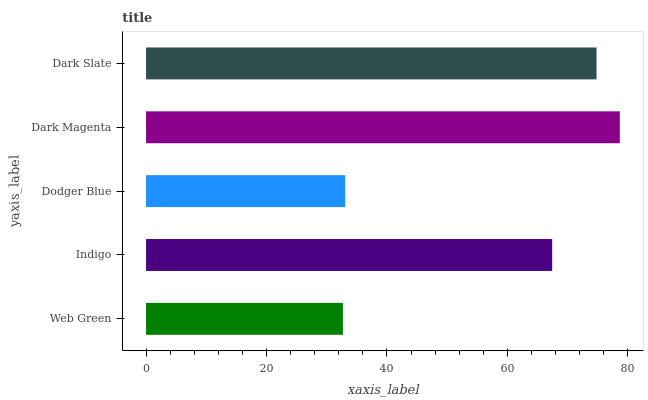Is Web Green the minimum?
Answer yes or no. Yes. Is Dark Magenta the maximum?
Answer yes or no. Yes. Is Indigo the minimum?
Answer yes or no. No. Is Indigo the maximum?
Answer yes or no. No. Is Indigo greater than Web Green?
Answer yes or no. Yes. Is Web Green less than Indigo?
Answer yes or no. Yes. Is Web Green greater than Indigo?
Answer yes or no. No. Is Indigo less than Web Green?
Answer yes or no. No. Is Indigo the high median?
Answer yes or no. Yes. Is Indigo the low median?
Answer yes or no. Yes. Is Dark Magenta the high median?
Answer yes or no. No. Is Dodger Blue the low median?
Answer yes or no. No. 